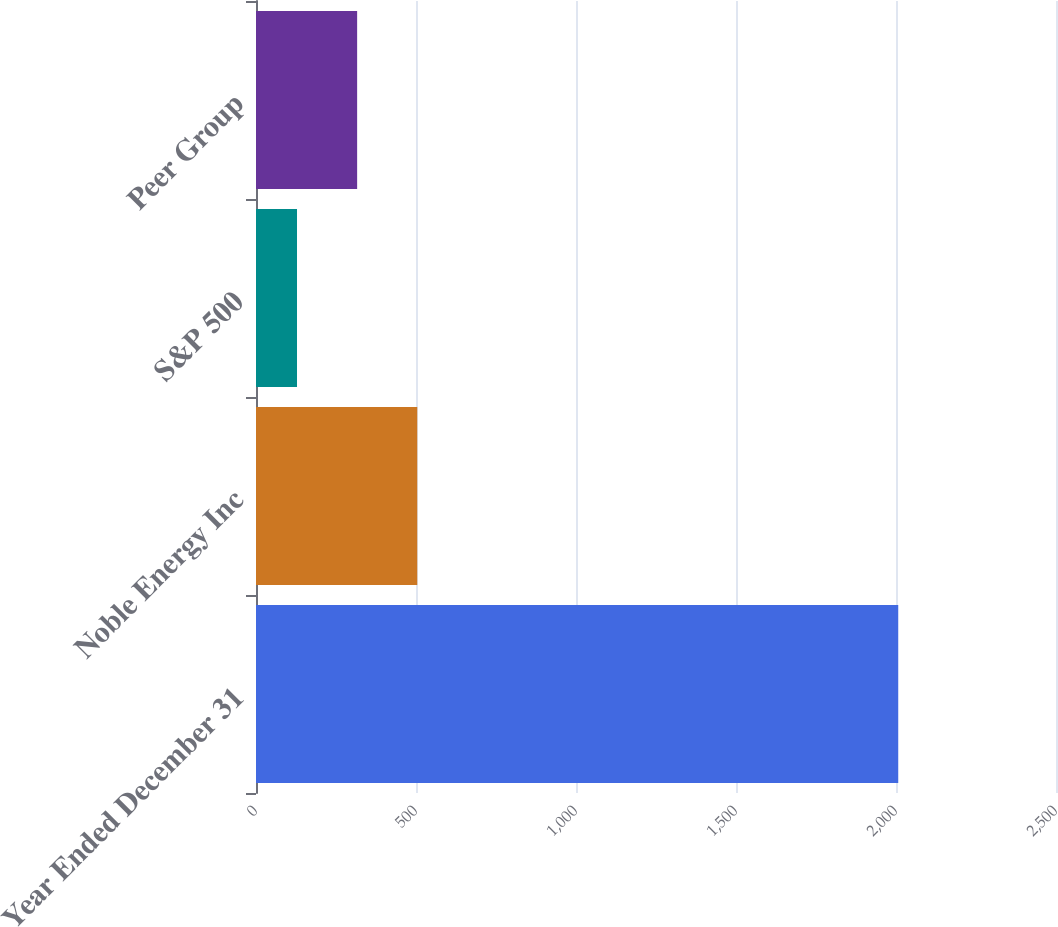<chart> <loc_0><loc_0><loc_500><loc_500><bar_chart><fcel>Year Ended December 31<fcel>Noble Energy Inc<fcel>S&P 500<fcel>Peer Group<nl><fcel>2007<fcel>503.92<fcel>128.16<fcel>316.04<nl></chart> 